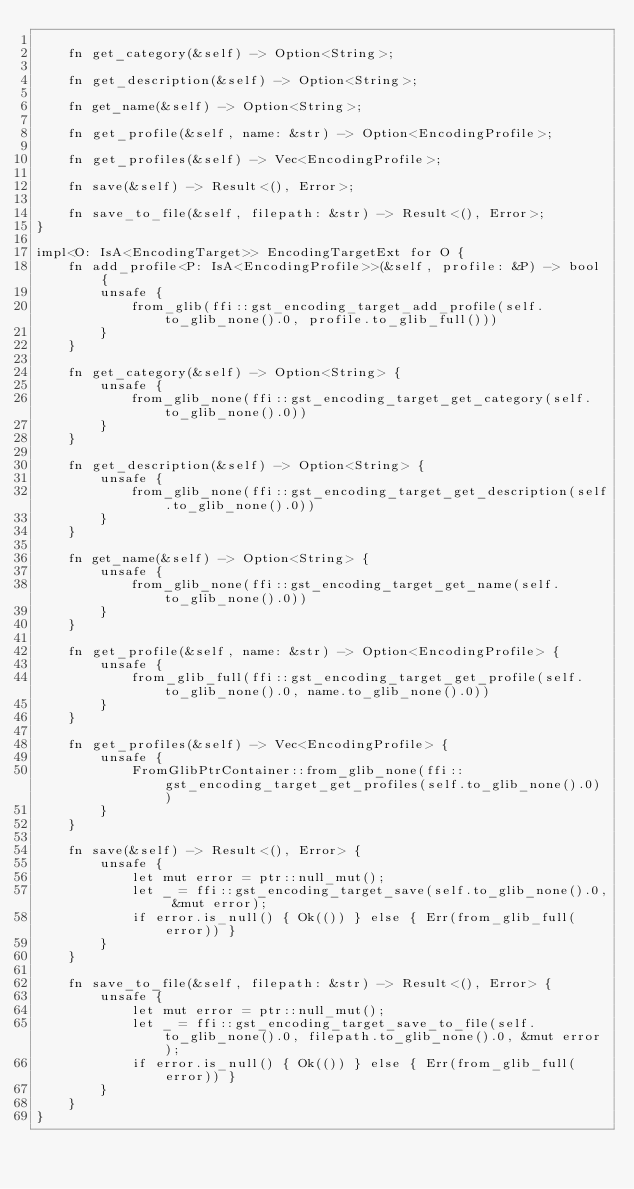Convert code to text. <code><loc_0><loc_0><loc_500><loc_500><_Rust_>
    fn get_category(&self) -> Option<String>;

    fn get_description(&self) -> Option<String>;

    fn get_name(&self) -> Option<String>;

    fn get_profile(&self, name: &str) -> Option<EncodingProfile>;

    fn get_profiles(&self) -> Vec<EncodingProfile>;

    fn save(&self) -> Result<(), Error>;

    fn save_to_file(&self, filepath: &str) -> Result<(), Error>;
}

impl<O: IsA<EncodingTarget>> EncodingTargetExt for O {
    fn add_profile<P: IsA<EncodingProfile>>(&self, profile: &P) -> bool {
        unsafe {
            from_glib(ffi::gst_encoding_target_add_profile(self.to_glib_none().0, profile.to_glib_full()))
        }
    }

    fn get_category(&self) -> Option<String> {
        unsafe {
            from_glib_none(ffi::gst_encoding_target_get_category(self.to_glib_none().0))
        }
    }

    fn get_description(&self) -> Option<String> {
        unsafe {
            from_glib_none(ffi::gst_encoding_target_get_description(self.to_glib_none().0))
        }
    }

    fn get_name(&self) -> Option<String> {
        unsafe {
            from_glib_none(ffi::gst_encoding_target_get_name(self.to_glib_none().0))
        }
    }

    fn get_profile(&self, name: &str) -> Option<EncodingProfile> {
        unsafe {
            from_glib_full(ffi::gst_encoding_target_get_profile(self.to_glib_none().0, name.to_glib_none().0))
        }
    }

    fn get_profiles(&self) -> Vec<EncodingProfile> {
        unsafe {
            FromGlibPtrContainer::from_glib_none(ffi::gst_encoding_target_get_profiles(self.to_glib_none().0))
        }
    }

    fn save(&self) -> Result<(), Error> {
        unsafe {
            let mut error = ptr::null_mut();
            let _ = ffi::gst_encoding_target_save(self.to_glib_none().0, &mut error);
            if error.is_null() { Ok(()) } else { Err(from_glib_full(error)) }
        }
    }

    fn save_to_file(&self, filepath: &str) -> Result<(), Error> {
        unsafe {
            let mut error = ptr::null_mut();
            let _ = ffi::gst_encoding_target_save_to_file(self.to_glib_none().0, filepath.to_glib_none().0, &mut error);
            if error.is_null() { Ok(()) } else { Err(from_glib_full(error)) }
        }
    }
}
</code> 